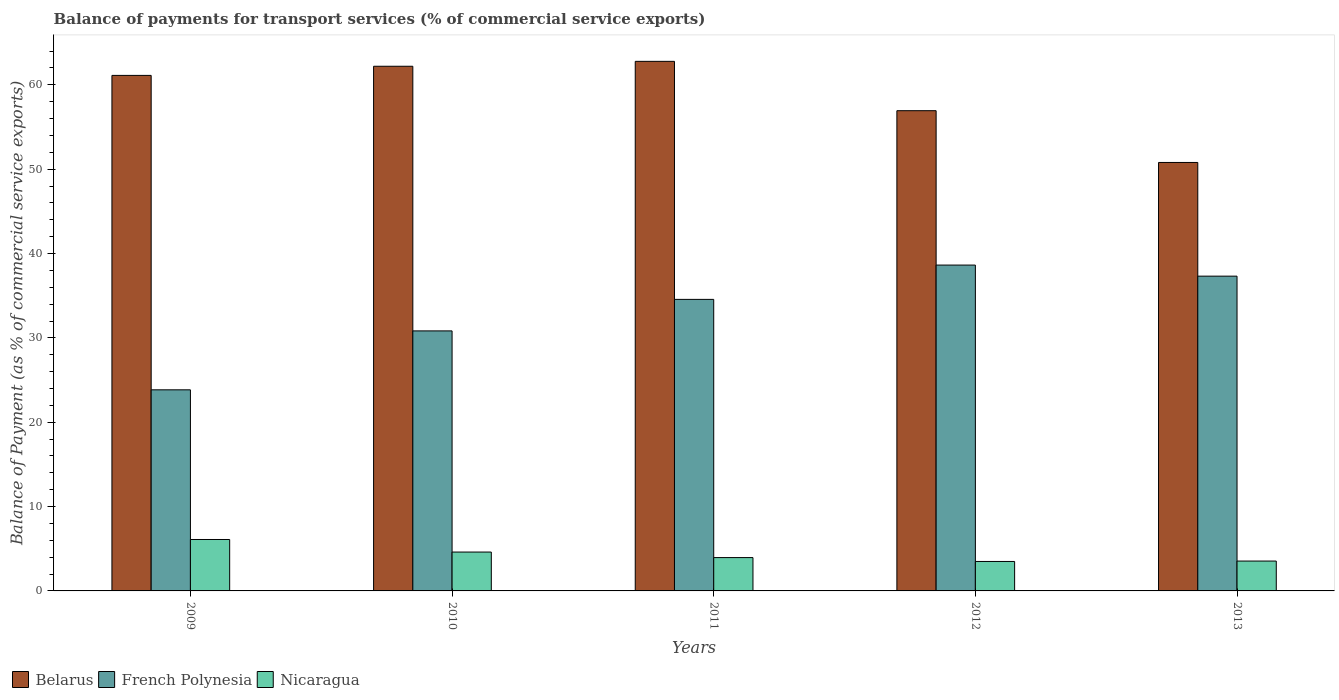How many groups of bars are there?
Your response must be concise. 5. How many bars are there on the 1st tick from the left?
Give a very brief answer. 3. How many bars are there on the 4th tick from the right?
Keep it short and to the point. 3. What is the label of the 1st group of bars from the left?
Ensure brevity in your answer.  2009. What is the balance of payments for transport services in French Polynesia in 2011?
Provide a short and direct response. 34.56. Across all years, what is the maximum balance of payments for transport services in Nicaragua?
Your answer should be very brief. 6.1. Across all years, what is the minimum balance of payments for transport services in Belarus?
Your response must be concise. 50.8. What is the total balance of payments for transport services in Nicaragua in the graph?
Your answer should be very brief. 21.69. What is the difference between the balance of payments for transport services in Nicaragua in 2009 and that in 2013?
Your answer should be very brief. 2.55. What is the difference between the balance of payments for transport services in Nicaragua in 2010 and the balance of payments for transport services in Belarus in 2012?
Ensure brevity in your answer.  -52.33. What is the average balance of payments for transport services in French Polynesia per year?
Your answer should be very brief. 33.04. In the year 2010, what is the difference between the balance of payments for transport services in French Polynesia and balance of payments for transport services in Nicaragua?
Offer a terse response. 26.22. In how many years, is the balance of payments for transport services in French Polynesia greater than 56 %?
Your answer should be compact. 0. What is the ratio of the balance of payments for transport services in Nicaragua in 2011 to that in 2012?
Make the answer very short. 1.13. Is the balance of payments for transport services in French Polynesia in 2010 less than that in 2013?
Make the answer very short. Yes. What is the difference between the highest and the second highest balance of payments for transport services in Nicaragua?
Your answer should be very brief. 1.49. What is the difference between the highest and the lowest balance of payments for transport services in Belarus?
Keep it short and to the point. 11.99. In how many years, is the balance of payments for transport services in Nicaragua greater than the average balance of payments for transport services in Nicaragua taken over all years?
Provide a succinct answer. 2. What does the 3rd bar from the left in 2013 represents?
Give a very brief answer. Nicaragua. What does the 2nd bar from the right in 2011 represents?
Your answer should be very brief. French Polynesia. How many bars are there?
Make the answer very short. 15. How many years are there in the graph?
Offer a terse response. 5. What is the difference between two consecutive major ticks on the Y-axis?
Provide a succinct answer. 10. Does the graph contain any zero values?
Give a very brief answer. No. Where does the legend appear in the graph?
Keep it short and to the point. Bottom left. How many legend labels are there?
Your answer should be compact. 3. How are the legend labels stacked?
Provide a short and direct response. Horizontal. What is the title of the graph?
Your answer should be very brief. Balance of payments for transport services (% of commercial service exports). What is the label or title of the X-axis?
Offer a very short reply. Years. What is the label or title of the Y-axis?
Keep it short and to the point. Balance of Payment (as % of commercial service exports). What is the Balance of Payment (as % of commercial service exports) of Belarus in 2009?
Provide a succinct answer. 61.12. What is the Balance of Payment (as % of commercial service exports) in French Polynesia in 2009?
Ensure brevity in your answer.  23.84. What is the Balance of Payment (as % of commercial service exports) of Nicaragua in 2009?
Provide a succinct answer. 6.1. What is the Balance of Payment (as % of commercial service exports) of Belarus in 2010?
Provide a succinct answer. 62.2. What is the Balance of Payment (as % of commercial service exports) of French Polynesia in 2010?
Provide a short and direct response. 30.83. What is the Balance of Payment (as % of commercial service exports) in Nicaragua in 2010?
Offer a terse response. 4.61. What is the Balance of Payment (as % of commercial service exports) in Belarus in 2011?
Your response must be concise. 62.78. What is the Balance of Payment (as % of commercial service exports) of French Polynesia in 2011?
Make the answer very short. 34.56. What is the Balance of Payment (as % of commercial service exports) in Nicaragua in 2011?
Provide a succinct answer. 3.95. What is the Balance of Payment (as % of commercial service exports) of Belarus in 2012?
Give a very brief answer. 56.93. What is the Balance of Payment (as % of commercial service exports) of French Polynesia in 2012?
Provide a succinct answer. 38.63. What is the Balance of Payment (as % of commercial service exports) of Nicaragua in 2012?
Offer a terse response. 3.49. What is the Balance of Payment (as % of commercial service exports) in Belarus in 2013?
Your answer should be compact. 50.8. What is the Balance of Payment (as % of commercial service exports) of French Polynesia in 2013?
Offer a very short reply. 37.32. What is the Balance of Payment (as % of commercial service exports) of Nicaragua in 2013?
Your answer should be compact. 3.54. Across all years, what is the maximum Balance of Payment (as % of commercial service exports) in Belarus?
Your answer should be very brief. 62.78. Across all years, what is the maximum Balance of Payment (as % of commercial service exports) of French Polynesia?
Offer a very short reply. 38.63. Across all years, what is the maximum Balance of Payment (as % of commercial service exports) in Nicaragua?
Your answer should be compact. 6.1. Across all years, what is the minimum Balance of Payment (as % of commercial service exports) of Belarus?
Give a very brief answer. 50.8. Across all years, what is the minimum Balance of Payment (as % of commercial service exports) in French Polynesia?
Keep it short and to the point. 23.84. Across all years, what is the minimum Balance of Payment (as % of commercial service exports) of Nicaragua?
Make the answer very short. 3.49. What is the total Balance of Payment (as % of commercial service exports) of Belarus in the graph?
Provide a succinct answer. 293.83. What is the total Balance of Payment (as % of commercial service exports) of French Polynesia in the graph?
Your response must be concise. 165.18. What is the total Balance of Payment (as % of commercial service exports) in Nicaragua in the graph?
Provide a short and direct response. 21.69. What is the difference between the Balance of Payment (as % of commercial service exports) in Belarus in 2009 and that in 2010?
Keep it short and to the point. -1.08. What is the difference between the Balance of Payment (as % of commercial service exports) of French Polynesia in 2009 and that in 2010?
Give a very brief answer. -6.99. What is the difference between the Balance of Payment (as % of commercial service exports) in Nicaragua in 2009 and that in 2010?
Provide a succinct answer. 1.49. What is the difference between the Balance of Payment (as % of commercial service exports) of Belarus in 2009 and that in 2011?
Your answer should be compact. -1.67. What is the difference between the Balance of Payment (as % of commercial service exports) in French Polynesia in 2009 and that in 2011?
Your answer should be very brief. -10.72. What is the difference between the Balance of Payment (as % of commercial service exports) of Nicaragua in 2009 and that in 2011?
Ensure brevity in your answer.  2.14. What is the difference between the Balance of Payment (as % of commercial service exports) in Belarus in 2009 and that in 2012?
Offer a terse response. 4.18. What is the difference between the Balance of Payment (as % of commercial service exports) of French Polynesia in 2009 and that in 2012?
Provide a succinct answer. -14.79. What is the difference between the Balance of Payment (as % of commercial service exports) of Nicaragua in 2009 and that in 2012?
Your answer should be very brief. 2.6. What is the difference between the Balance of Payment (as % of commercial service exports) in Belarus in 2009 and that in 2013?
Make the answer very short. 10.32. What is the difference between the Balance of Payment (as % of commercial service exports) in French Polynesia in 2009 and that in 2013?
Offer a very short reply. -13.48. What is the difference between the Balance of Payment (as % of commercial service exports) in Nicaragua in 2009 and that in 2013?
Provide a short and direct response. 2.56. What is the difference between the Balance of Payment (as % of commercial service exports) in Belarus in 2010 and that in 2011?
Give a very brief answer. -0.58. What is the difference between the Balance of Payment (as % of commercial service exports) in French Polynesia in 2010 and that in 2011?
Keep it short and to the point. -3.74. What is the difference between the Balance of Payment (as % of commercial service exports) in Nicaragua in 2010 and that in 2011?
Keep it short and to the point. 0.66. What is the difference between the Balance of Payment (as % of commercial service exports) in Belarus in 2010 and that in 2012?
Offer a terse response. 5.27. What is the difference between the Balance of Payment (as % of commercial service exports) in French Polynesia in 2010 and that in 2012?
Give a very brief answer. -7.8. What is the difference between the Balance of Payment (as % of commercial service exports) in Nicaragua in 2010 and that in 2012?
Ensure brevity in your answer.  1.12. What is the difference between the Balance of Payment (as % of commercial service exports) in Belarus in 2010 and that in 2013?
Give a very brief answer. 11.4. What is the difference between the Balance of Payment (as % of commercial service exports) of French Polynesia in 2010 and that in 2013?
Make the answer very short. -6.49. What is the difference between the Balance of Payment (as % of commercial service exports) of Nicaragua in 2010 and that in 2013?
Your answer should be very brief. 1.07. What is the difference between the Balance of Payment (as % of commercial service exports) in Belarus in 2011 and that in 2012?
Make the answer very short. 5.85. What is the difference between the Balance of Payment (as % of commercial service exports) in French Polynesia in 2011 and that in 2012?
Give a very brief answer. -4.07. What is the difference between the Balance of Payment (as % of commercial service exports) in Nicaragua in 2011 and that in 2012?
Make the answer very short. 0.46. What is the difference between the Balance of Payment (as % of commercial service exports) in Belarus in 2011 and that in 2013?
Make the answer very short. 11.99. What is the difference between the Balance of Payment (as % of commercial service exports) of French Polynesia in 2011 and that in 2013?
Ensure brevity in your answer.  -2.75. What is the difference between the Balance of Payment (as % of commercial service exports) of Nicaragua in 2011 and that in 2013?
Offer a very short reply. 0.41. What is the difference between the Balance of Payment (as % of commercial service exports) in Belarus in 2012 and that in 2013?
Offer a terse response. 6.14. What is the difference between the Balance of Payment (as % of commercial service exports) in French Polynesia in 2012 and that in 2013?
Give a very brief answer. 1.31. What is the difference between the Balance of Payment (as % of commercial service exports) in Nicaragua in 2012 and that in 2013?
Your response must be concise. -0.05. What is the difference between the Balance of Payment (as % of commercial service exports) in Belarus in 2009 and the Balance of Payment (as % of commercial service exports) in French Polynesia in 2010?
Make the answer very short. 30.29. What is the difference between the Balance of Payment (as % of commercial service exports) of Belarus in 2009 and the Balance of Payment (as % of commercial service exports) of Nicaragua in 2010?
Ensure brevity in your answer.  56.51. What is the difference between the Balance of Payment (as % of commercial service exports) of French Polynesia in 2009 and the Balance of Payment (as % of commercial service exports) of Nicaragua in 2010?
Offer a terse response. 19.23. What is the difference between the Balance of Payment (as % of commercial service exports) of Belarus in 2009 and the Balance of Payment (as % of commercial service exports) of French Polynesia in 2011?
Offer a terse response. 26.55. What is the difference between the Balance of Payment (as % of commercial service exports) of Belarus in 2009 and the Balance of Payment (as % of commercial service exports) of Nicaragua in 2011?
Your response must be concise. 57.17. What is the difference between the Balance of Payment (as % of commercial service exports) in French Polynesia in 2009 and the Balance of Payment (as % of commercial service exports) in Nicaragua in 2011?
Ensure brevity in your answer.  19.89. What is the difference between the Balance of Payment (as % of commercial service exports) of Belarus in 2009 and the Balance of Payment (as % of commercial service exports) of French Polynesia in 2012?
Offer a terse response. 22.49. What is the difference between the Balance of Payment (as % of commercial service exports) in Belarus in 2009 and the Balance of Payment (as % of commercial service exports) in Nicaragua in 2012?
Your answer should be very brief. 57.63. What is the difference between the Balance of Payment (as % of commercial service exports) in French Polynesia in 2009 and the Balance of Payment (as % of commercial service exports) in Nicaragua in 2012?
Give a very brief answer. 20.35. What is the difference between the Balance of Payment (as % of commercial service exports) of Belarus in 2009 and the Balance of Payment (as % of commercial service exports) of French Polynesia in 2013?
Your answer should be very brief. 23.8. What is the difference between the Balance of Payment (as % of commercial service exports) of Belarus in 2009 and the Balance of Payment (as % of commercial service exports) of Nicaragua in 2013?
Ensure brevity in your answer.  57.58. What is the difference between the Balance of Payment (as % of commercial service exports) in French Polynesia in 2009 and the Balance of Payment (as % of commercial service exports) in Nicaragua in 2013?
Make the answer very short. 20.3. What is the difference between the Balance of Payment (as % of commercial service exports) in Belarus in 2010 and the Balance of Payment (as % of commercial service exports) in French Polynesia in 2011?
Your answer should be compact. 27.64. What is the difference between the Balance of Payment (as % of commercial service exports) in Belarus in 2010 and the Balance of Payment (as % of commercial service exports) in Nicaragua in 2011?
Keep it short and to the point. 58.25. What is the difference between the Balance of Payment (as % of commercial service exports) of French Polynesia in 2010 and the Balance of Payment (as % of commercial service exports) of Nicaragua in 2011?
Offer a very short reply. 26.88. What is the difference between the Balance of Payment (as % of commercial service exports) in Belarus in 2010 and the Balance of Payment (as % of commercial service exports) in French Polynesia in 2012?
Give a very brief answer. 23.57. What is the difference between the Balance of Payment (as % of commercial service exports) in Belarus in 2010 and the Balance of Payment (as % of commercial service exports) in Nicaragua in 2012?
Offer a very short reply. 58.71. What is the difference between the Balance of Payment (as % of commercial service exports) of French Polynesia in 2010 and the Balance of Payment (as % of commercial service exports) of Nicaragua in 2012?
Your answer should be very brief. 27.34. What is the difference between the Balance of Payment (as % of commercial service exports) of Belarus in 2010 and the Balance of Payment (as % of commercial service exports) of French Polynesia in 2013?
Your response must be concise. 24.88. What is the difference between the Balance of Payment (as % of commercial service exports) of Belarus in 2010 and the Balance of Payment (as % of commercial service exports) of Nicaragua in 2013?
Your answer should be compact. 58.66. What is the difference between the Balance of Payment (as % of commercial service exports) in French Polynesia in 2010 and the Balance of Payment (as % of commercial service exports) in Nicaragua in 2013?
Make the answer very short. 27.29. What is the difference between the Balance of Payment (as % of commercial service exports) of Belarus in 2011 and the Balance of Payment (as % of commercial service exports) of French Polynesia in 2012?
Give a very brief answer. 24.15. What is the difference between the Balance of Payment (as % of commercial service exports) of Belarus in 2011 and the Balance of Payment (as % of commercial service exports) of Nicaragua in 2012?
Provide a short and direct response. 59.29. What is the difference between the Balance of Payment (as % of commercial service exports) of French Polynesia in 2011 and the Balance of Payment (as % of commercial service exports) of Nicaragua in 2012?
Make the answer very short. 31.07. What is the difference between the Balance of Payment (as % of commercial service exports) in Belarus in 2011 and the Balance of Payment (as % of commercial service exports) in French Polynesia in 2013?
Your answer should be compact. 25.46. What is the difference between the Balance of Payment (as % of commercial service exports) in Belarus in 2011 and the Balance of Payment (as % of commercial service exports) in Nicaragua in 2013?
Your answer should be compact. 59.24. What is the difference between the Balance of Payment (as % of commercial service exports) in French Polynesia in 2011 and the Balance of Payment (as % of commercial service exports) in Nicaragua in 2013?
Keep it short and to the point. 31.02. What is the difference between the Balance of Payment (as % of commercial service exports) in Belarus in 2012 and the Balance of Payment (as % of commercial service exports) in French Polynesia in 2013?
Your answer should be compact. 19.62. What is the difference between the Balance of Payment (as % of commercial service exports) in Belarus in 2012 and the Balance of Payment (as % of commercial service exports) in Nicaragua in 2013?
Provide a succinct answer. 53.39. What is the difference between the Balance of Payment (as % of commercial service exports) in French Polynesia in 2012 and the Balance of Payment (as % of commercial service exports) in Nicaragua in 2013?
Provide a succinct answer. 35.09. What is the average Balance of Payment (as % of commercial service exports) of Belarus per year?
Offer a terse response. 58.77. What is the average Balance of Payment (as % of commercial service exports) in French Polynesia per year?
Your answer should be very brief. 33.04. What is the average Balance of Payment (as % of commercial service exports) in Nicaragua per year?
Your answer should be very brief. 4.34. In the year 2009, what is the difference between the Balance of Payment (as % of commercial service exports) of Belarus and Balance of Payment (as % of commercial service exports) of French Polynesia?
Make the answer very short. 37.28. In the year 2009, what is the difference between the Balance of Payment (as % of commercial service exports) in Belarus and Balance of Payment (as % of commercial service exports) in Nicaragua?
Provide a short and direct response. 55.02. In the year 2009, what is the difference between the Balance of Payment (as % of commercial service exports) in French Polynesia and Balance of Payment (as % of commercial service exports) in Nicaragua?
Your answer should be compact. 17.75. In the year 2010, what is the difference between the Balance of Payment (as % of commercial service exports) in Belarus and Balance of Payment (as % of commercial service exports) in French Polynesia?
Provide a succinct answer. 31.37. In the year 2010, what is the difference between the Balance of Payment (as % of commercial service exports) of Belarus and Balance of Payment (as % of commercial service exports) of Nicaragua?
Ensure brevity in your answer.  57.59. In the year 2010, what is the difference between the Balance of Payment (as % of commercial service exports) in French Polynesia and Balance of Payment (as % of commercial service exports) in Nicaragua?
Give a very brief answer. 26.22. In the year 2011, what is the difference between the Balance of Payment (as % of commercial service exports) of Belarus and Balance of Payment (as % of commercial service exports) of French Polynesia?
Provide a succinct answer. 28.22. In the year 2011, what is the difference between the Balance of Payment (as % of commercial service exports) in Belarus and Balance of Payment (as % of commercial service exports) in Nicaragua?
Ensure brevity in your answer.  58.83. In the year 2011, what is the difference between the Balance of Payment (as % of commercial service exports) in French Polynesia and Balance of Payment (as % of commercial service exports) in Nicaragua?
Ensure brevity in your answer.  30.61. In the year 2012, what is the difference between the Balance of Payment (as % of commercial service exports) in Belarus and Balance of Payment (as % of commercial service exports) in French Polynesia?
Give a very brief answer. 18.3. In the year 2012, what is the difference between the Balance of Payment (as % of commercial service exports) in Belarus and Balance of Payment (as % of commercial service exports) in Nicaragua?
Offer a very short reply. 53.44. In the year 2012, what is the difference between the Balance of Payment (as % of commercial service exports) in French Polynesia and Balance of Payment (as % of commercial service exports) in Nicaragua?
Your answer should be compact. 35.14. In the year 2013, what is the difference between the Balance of Payment (as % of commercial service exports) in Belarus and Balance of Payment (as % of commercial service exports) in French Polynesia?
Offer a very short reply. 13.48. In the year 2013, what is the difference between the Balance of Payment (as % of commercial service exports) in Belarus and Balance of Payment (as % of commercial service exports) in Nicaragua?
Give a very brief answer. 47.26. In the year 2013, what is the difference between the Balance of Payment (as % of commercial service exports) in French Polynesia and Balance of Payment (as % of commercial service exports) in Nicaragua?
Provide a succinct answer. 33.78. What is the ratio of the Balance of Payment (as % of commercial service exports) in Belarus in 2009 to that in 2010?
Provide a succinct answer. 0.98. What is the ratio of the Balance of Payment (as % of commercial service exports) in French Polynesia in 2009 to that in 2010?
Make the answer very short. 0.77. What is the ratio of the Balance of Payment (as % of commercial service exports) in Nicaragua in 2009 to that in 2010?
Make the answer very short. 1.32. What is the ratio of the Balance of Payment (as % of commercial service exports) in Belarus in 2009 to that in 2011?
Your answer should be very brief. 0.97. What is the ratio of the Balance of Payment (as % of commercial service exports) of French Polynesia in 2009 to that in 2011?
Provide a succinct answer. 0.69. What is the ratio of the Balance of Payment (as % of commercial service exports) of Nicaragua in 2009 to that in 2011?
Give a very brief answer. 1.54. What is the ratio of the Balance of Payment (as % of commercial service exports) of Belarus in 2009 to that in 2012?
Offer a very short reply. 1.07. What is the ratio of the Balance of Payment (as % of commercial service exports) in French Polynesia in 2009 to that in 2012?
Keep it short and to the point. 0.62. What is the ratio of the Balance of Payment (as % of commercial service exports) in Nicaragua in 2009 to that in 2012?
Provide a short and direct response. 1.75. What is the ratio of the Balance of Payment (as % of commercial service exports) in Belarus in 2009 to that in 2013?
Make the answer very short. 1.2. What is the ratio of the Balance of Payment (as % of commercial service exports) of French Polynesia in 2009 to that in 2013?
Keep it short and to the point. 0.64. What is the ratio of the Balance of Payment (as % of commercial service exports) of Nicaragua in 2009 to that in 2013?
Your response must be concise. 1.72. What is the ratio of the Balance of Payment (as % of commercial service exports) of French Polynesia in 2010 to that in 2011?
Your answer should be very brief. 0.89. What is the ratio of the Balance of Payment (as % of commercial service exports) in Nicaragua in 2010 to that in 2011?
Your answer should be compact. 1.17. What is the ratio of the Balance of Payment (as % of commercial service exports) in Belarus in 2010 to that in 2012?
Make the answer very short. 1.09. What is the ratio of the Balance of Payment (as % of commercial service exports) in French Polynesia in 2010 to that in 2012?
Your response must be concise. 0.8. What is the ratio of the Balance of Payment (as % of commercial service exports) of Nicaragua in 2010 to that in 2012?
Offer a terse response. 1.32. What is the ratio of the Balance of Payment (as % of commercial service exports) of Belarus in 2010 to that in 2013?
Ensure brevity in your answer.  1.22. What is the ratio of the Balance of Payment (as % of commercial service exports) in French Polynesia in 2010 to that in 2013?
Your response must be concise. 0.83. What is the ratio of the Balance of Payment (as % of commercial service exports) in Nicaragua in 2010 to that in 2013?
Your response must be concise. 1.3. What is the ratio of the Balance of Payment (as % of commercial service exports) in Belarus in 2011 to that in 2012?
Your answer should be very brief. 1.1. What is the ratio of the Balance of Payment (as % of commercial service exports) of French Polynesia in 2011 to that in 2012?
Your response must be concise. 0.89. What is the ratio of the Balance of Payment (as % of commercial service exports) of Nicaragua in 2011 to that in 2012?
Your response must be concise. 1.13. What is the ratio of the Balance of Payment (as % of commercial service exports) of Belarus in 2011 to that in 2013?
Give a very brief answer. 1.24. What is the ratio of the Balance of Payment (as % of commercial service exports) in French Polynesia in 2011 to that in 2013?
Provide a succinct answer. 0.93. What is the ratio of the Balance of Payment (as % of commercial service exports) of Nicaragua in 2011 to that in 2013?
Provide a succinct answer. 1.12. What is the ratio of the Balance of Payment (as % of commercial service exports) of Belarus in 2012 to that in 2013?
Your response must be concise. 1.12. What is the ratio of the Balance of Payment (as % of commercial service exports) of French Polynesia in 2012 to that in 2013?
Offer a terse response. 1.04. What is the ratio of the Balance of Payment (as % of commercial service exports) in Nicaragua in 2012 to that in 2013?
Offer a very short reply. 0.99. What is the difference between the highest and the second highest Balance of Payment (as % of commercial service exports) of Belarus?
Offer a terse response. 0.58. What is the difference between the highest and the second highest Balance of Payment (as % of commercial service exports) of French Polynesia?
Keep it short and to the point. 1.31. What is the difference between the highest and the second highest Balance of Payment (as % of commercial service exports) of Nicaragua?
Give a very brief answer. 1.49. What is the difference between the highest and the lowest Balance of Payment (as % of commercial service exports) of Belarus?
Make the answer very short. 11.99. What is the difference between the highest and the lowest Balance of Payment (as % of commercial service exports) of French Polynesia?
Keep it short and to the point. 14.79. What is the difference between the highest and the lowest Balance of Payment (as % of commercial service exports) of Nicaragua?
Provide a short and direct response. 2.6. 